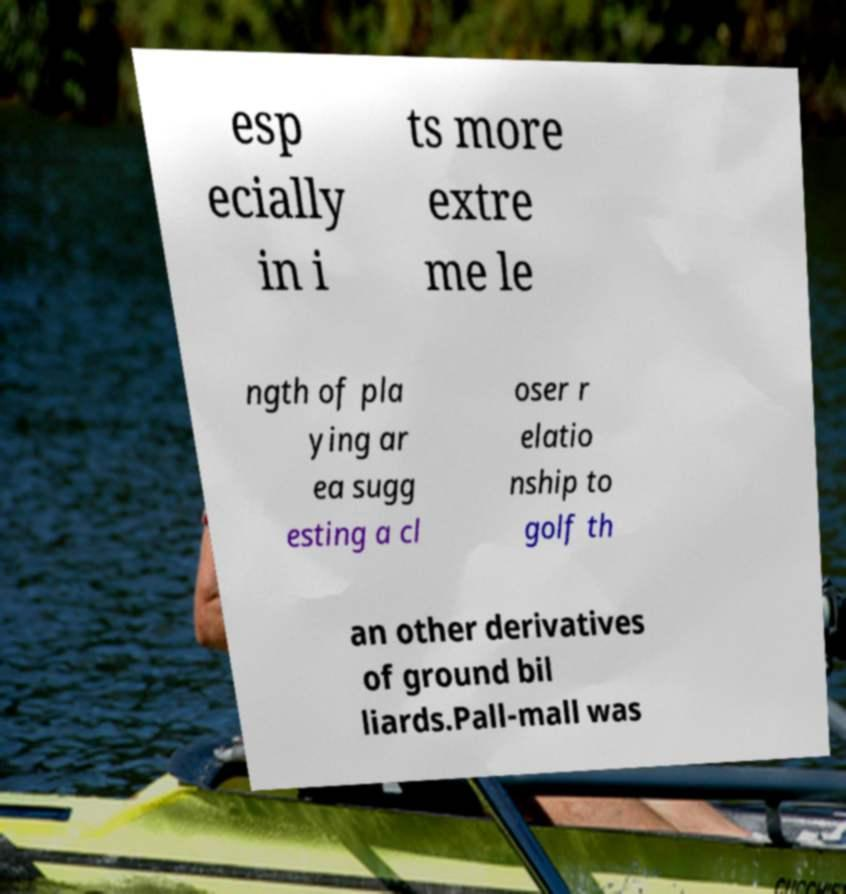Could you extract and type out the text from this image? esp ecially in i ts more extre me le ngth of pla ying ar ea sugg esting a cl oser r elatio nship to golf th an other derivatives of ground bil liards.Pall-mall was 